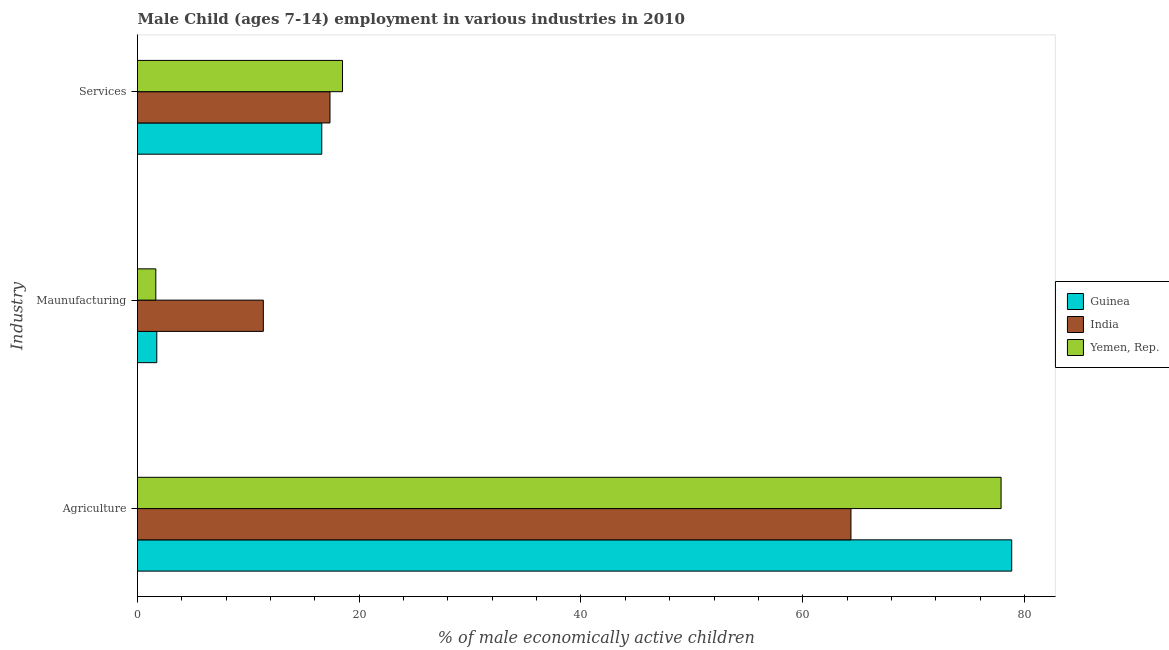How many different coloured bars are there?
Your answer should be very brief. 3. How many groups of bars are there?
Offer a terse response. 3. How many bars are there on the 2nd tick from the top?
Make the answer very short. 3. What is the label of the 1st group of bars from the top?
Offer a very short reply. Services. What is the percentage of economically active children in services in India?
Provide a short and direct response. 17.36. Across all countries, what is the maximum percentage of economically active children in manufacturing?
Make the answer very short. 11.35. Across all countries, what is the minimum percentage of economically active children in manufacturing?
Your response must be concise. 1.65. In which country was the percentage of economically active children in agriculture maximum?
Your answer should be compact. Guinea. In which country was the percentage of economically active children in agriculture minimum?
Ensure brevity in your answer.  India. What is the total percentage of economically active children in agriculture in the graph?
Offer a terse response. 221.09. What is the difference between the percentage of economically active children in services in Yemen, Rep. and that in India?
Your answer should be very brief. 1.13. What is the difference between the percentage of economically active children in manufacturing in Yemen, Rep. and the percentage of economically active children in agriculture in Guinea?
Ensure brevity in your answer.  -77.2. What is the average percentage of economically active children in services per country?
Keep it short and to the point. 17.49. What is the difference between the percentage of economically active children in services and percentage of economically active children in manufacturing in Guinea?
Your answer should be very brief. 14.88. In how many countries, is the percentage of economically active children in services greater than 20 %?
Keep it short and to the point. 0. What is the ratio of the percentage of economically active children in services in Yemen, Rep. to that in Guinea?
Your answer should be compact. 1.11. Is the percentage of economically active children in agriculture in Guinea less than that in India?
Offer a very short reply. No. Is the difference between the percentage of economically active children in services in Guinea and India greater than the difference between the percentage of economically active children in manufacturing in Guinea and India?
Your response must be concise. Yes. What is the difference between the highest and the second highest percentage of economically active children in manufacturing?
Your answer should be compact. 9.61. What is the difference between the highest and the lowest percentage of economically active children in manufacturing?
Offer a very short reply. 9.7. In how many countries, is the percentage of economically active children in agriculture greater than the average percentage of economically active children in agriculture taken over all countries?
Give a very brief answer. 2. Is the sum of the percentage of economically active children in services in India and Yemen, Rep. greater than the maximum percentage of economically active children in manufacturing across all countries?
Provide a short and direct response. Yes. What does the 3rd bar from the top in Agriculture represents?
Make the answer very short. Guinea. Is it the case that in every country, the sum of the percentage of economically active children in agriculture and percentage of economically active children in manufacturing is greater than the percentage of economically active children in services?
Give a very brief answer. Yes. How many bars are there?
Make the answer very short. 9. What is the difference between two consecutive major ticks on the X-axis?
Offer a terse response. 20. Does the graph contain any zero values?
Your answer should be compact. No. Does the graph contain grids?
Offer a terse response. No. How many legend labels are there?
Give a very brief answer. 3. How are the legend labels stacked?
Offer a very short reply. Vertical. What is the title of the graph?
Give a very brief answer. Male Child (ages 7-14) employment in various industries in 2010. Does "Pacific island small states" appear as one of the legend labels in the graph?
Provide a short and direct response. No. What is the label or title of the X-axis?
Provide a short and direct response. % of male economically active children. What is the label or title of the Y-axis?
Your answer should be very brief. Industry. What is the % of male economically active children in Guinea in Agriculture?
Offer a very short reply. 78.85. What is the % of male economically active children of India in Agriculture?
Make the answer very short. 64.35. What is the % of male economically active children of Yemen, Rep. in Agriculture?
Your answer should be very brief. 77.89. What is the % of male economically active children in Guinea in Maunufacturing?
Offer a terse response. 1.74. What is the % of male economically active children in India in Maunufacturing?
Keep it short and to the point. 11.35. What is the % of male economically active children in Yemen, Rep. in Maunufacturing?
Offer a very short reply. 1.65. What is the % of male economically active children in Guinea in Services?
Offer a very short reply. 16.62. What is the % of male economically active children of India in Services?
Provide a succinct answer. 17.36. What is the % of male economically active children in Yemen, Rep. in Services?
Provide a succinct answer. 18.49. Across all Industry, what is the maximum % of male economically active children in Guinea?
Your answer should be very brief. 78.85. Across all Industry, what is the maximum % of male economically active children of India?
Offer a very short reply. 64.35. Across all Industry, what is the maximum % of male economically active children of Yemen, Rep.?
Your answer should be very brief. 77.89. Across all Industry, what is the minimum % of male economically active children of Guinea?
Your response must be concise. 1.74. Across all Industry, what is the minimum % of male economically active children of India?
Give a very brief answer. 11.35. Across all Industry, what is the minimum % of male economically active children in Yemen, Rep.?
Your answer should be very brief. 1.65. What is the total % of male economically active children in Guinea in the graph?
Offer a terse response. 97.21. What is the total % of male economically active children in India in the graph?
Provide a short and direct response. 93.06. What is the total % of male economically active children of Yemen, Rep. in the graph?
Your answer should be very brief. 98.03. What is the difference between the % of male economically active children in Guinea in Agriculture and that in Maunufacturing?
Ensure brevity in your answer.  77.11. What is the difference between the % of male economically active children of India in Agriculture and that in Maunufacturing?
Give a very brief answer. 53. What is the difference between the % of male economically active children in Yemen, Rep. in Agriculture and that in Maunufacturing?
Provide a short and direct response. 76.24. What is the difference between the % of male economically active children in Guinea in Agriculture and that in Services?
Keep it short and to the point. 62.23. What is the difference between the % of male economically active children of India in Agriculture and that in Services?
Keep it short and to the point. 46.99. What is the difference between the % of male economically active children in Yemen, Rep. in Agriculture and that in Services?
Provide a succinct answer. 59.4. What is the difference between the % of male economically active children in Guinea in Maunufacturing and that in Services?
Provide a short and direct response. -14.88. What is the difference between the % of male economically active children in India in Maunufacturing and that in Services?
Give a very brief answer. -6.01. What is the difference between the % of male economically active children in Yemen, Rep. in Maunufacturing and that in Services?
Provide a succinct answer. -16.84. What is the difference between the % of male economically active children in Guinea in Agriculture and the % of male economically active children in India in Maunufacturing?
Offer a terse response. 67.5. What is the difference between the % of male economically active children in Guinea in Agriculture and the % of male economically active children in Yemen, Rep. in Maunufacturing?
Provide a short and direct response. 77.2. What is the difference between the % of male economically active children of India in Agriculture and the % of male economically active children of Yemen, Rep. in Maunufacturing?
Provide a succinct answer. 62.7. What is the difference between the % of male economically active children in Guinea in Agriculture and the % of male economically active children in India in Services?
Ensure brevity in your answer.  61.49. What is the difference between the % of male economically active children of Guinea in Agriculture and the % of male economically active children of Yemen, Rep. in Services?
Offer a very short reply. 60.36. What is the difference between the % of male economically active children of India in Agriculture and the % of male economically active children of Yemen, Rep. in Services?
Keep it short and to the point. 45.86. What is the difference between the % of male economically active children of Guinea in Maunufacturing and the % of male economically active children of India in Services?
Your answer should be compact. -15.62. What is the difference between the % of male economically active children in Guinea in Maunufacturing and the % of male economically active children in Yemen, Rep. in Services?
Keep it short and to the point. -16.75. What is the difference between the % of male economically active children of India in Maunufacturing and the % of male economically active children of Yemen, Rep. in Services?
Your answer should be very brief. -7.14. What is the average % of male economically active children of Guinea per Industry?
Your response must be concise. 32.4. What is the average % of male economically active children of India per Industry?
Offer a terse response. 31.02. What is the average % of male economically active children of Yemen, Rep. per Industry?
Provide a succinct answer. 32.68. What is the difference between the % of male economically active children of Guinea and % of male economically active children of Yemen, Rep. in Agriculture?
Provide a succinct answer. 0.96. What is the difference between the % of male economically active children of India and % of male economically active children of Yemen, Rep. in Agriculture?
Offer a terse response. -13.54. What is the difference between the % of male economically active children of Guinea and % of male economically active children of India in Maunufacturing?
Your response must be concise. -9.61. What is the difference between the % of male economically active children in Guinea and % of male economically active children in Yemen, Rep. in Maunufacturing?
Keep it short and to the point. 0.09. What is the difference between the % of male economically active children in Guinea and % of male economically active children in India in Services?
Make the answer very short. -0.74. What is the difference between the % of male economically active children of Guinea and % of male economically active children of Yemen, Rep. in Services?
Provide a short and direct response. -1.87. What is the difference between the % of male economically active children of India and % of male economically active children of Yemen, Rep. in Services?
Ensure brevity in your answer.  -1.13. What is the ratio of the % of male economically active children in Guinea in Agriculture to that in Maunufacturing?
Offer a terse response. 45.32. What is the ratio of the % of male economically active children in India in Agriculture to that in Maunufacturing?
Offer a terse response. 5.67. What is the ratio of the % of male economically active children in Yemen, Rep. in Agriculture to that in Maunufacturing?
Offer a very short reply. 47.21. What is the ratio of the % of male economically active children of Guinea in Agriculture to that in Services?
Provide a succinct answer. 4.74. What is the ratio of the % of male economically active children in India in Agriculture to that in Services?
Give a very brief answer. 3.71. What is the ratio of the % of male economically active children in Yemen, Rep. in Agriculture to that in Services?
Your response must be concise. 4.21. What is the ratio of the % of male economically active children of Guinea in Maunufacturing to that in Services?
Give a very brief answer. 0.1. What is the ratio of the % of male economically active children in India in Maunufacturing to that in Services?
Your answer should be compact. 0.65. What is the ratio of the % of male economically active children in Yemen, Rep. in Maunufacturing to that in Services?
Your answer should be compact. 0.09. What is the difference between the highest and the second highest % of male economically active children in Guinea?
Provide a succinct answer. 62.23. What is the difference between the highest and the second highest % of male economically active children of India?
Provide a short and direct response. 46.99. What is the difference between the highest and the second highest % of male economically active children in Yemen, Rep.?
Offer a very short reply. 59.4. What is the difference between the highest and the lowest % of male economically active children of Guinea?
Ensure brevity in your answer.  77.11. What is the difference between the highest and the lowest % of male economically active children in India?
Your response must be concise. 53. What is the difference between the highest and the lowest % of male economically active children of Yemen, Rep.?
Ensure brevity in your answer.  76.24. 